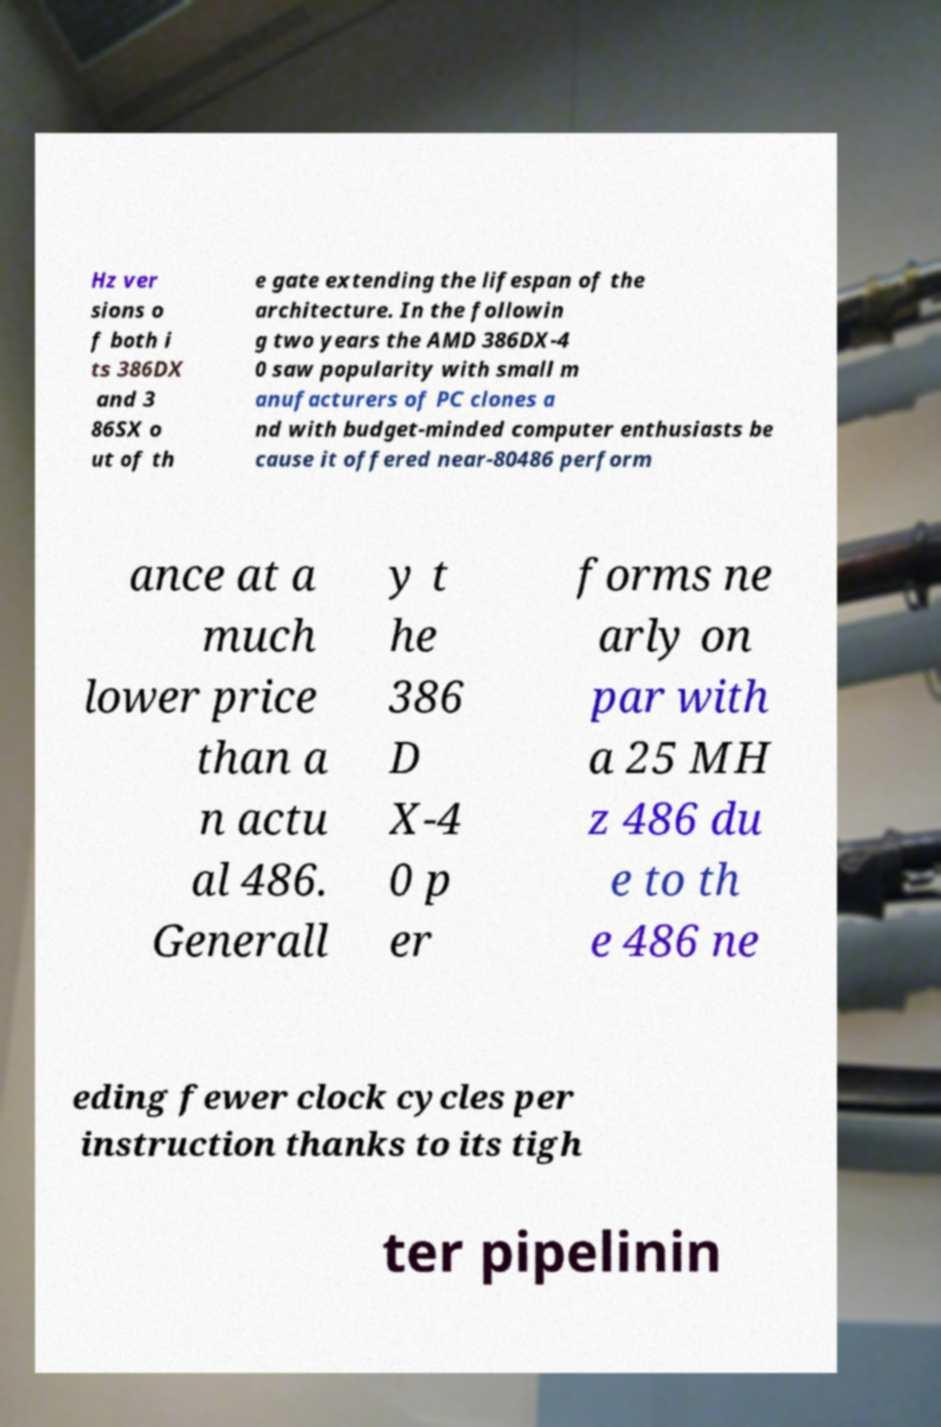Can you read and provide the text displayed in the image?This photo seems to have some interesting text. Can you extract and type it out for me? Hz ver sions o f both i ts 386DX and 3 86SX o ut of th e gate extending the lifespan of the architecture. In the followin g two years the AMD 386DX-4 0 saw popularity with small m anufacturers of PC clones a nd with budget-minded computer enthusiasts be cause it offered near-80486 perform ance at a much lower price than a n actu al 486. Generall y t he 386 D X-4 0 p er forms ne arly on par with a 25 MH z 486 du e to th e 486 ne eding fewer clock cycles per instruction thanks to its tigh ter pipelinin 